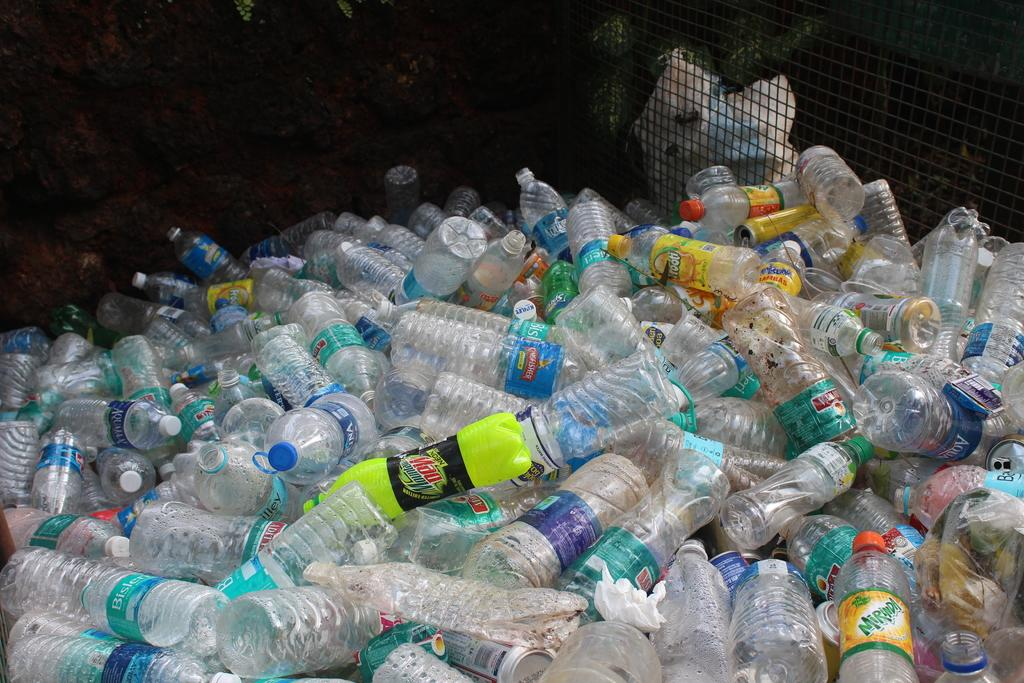What is the main subject of the image? The main subject of the image is a heap of plastic bottles. Can you describe the appearance of the plastic bottles? The plastic bottles are piled up in a heap. What might be the purpose of the plastic bottles? The plastic bottles might be used for storing liquids or as recyclable materials. What type of soda is being served at the station in the image? There is no soda or station present in the image; it only features a heap of plastic bottles. What is being served for lunch in the image? There is no lunch or food present in the image; it only features a heap of plastic bottles. 